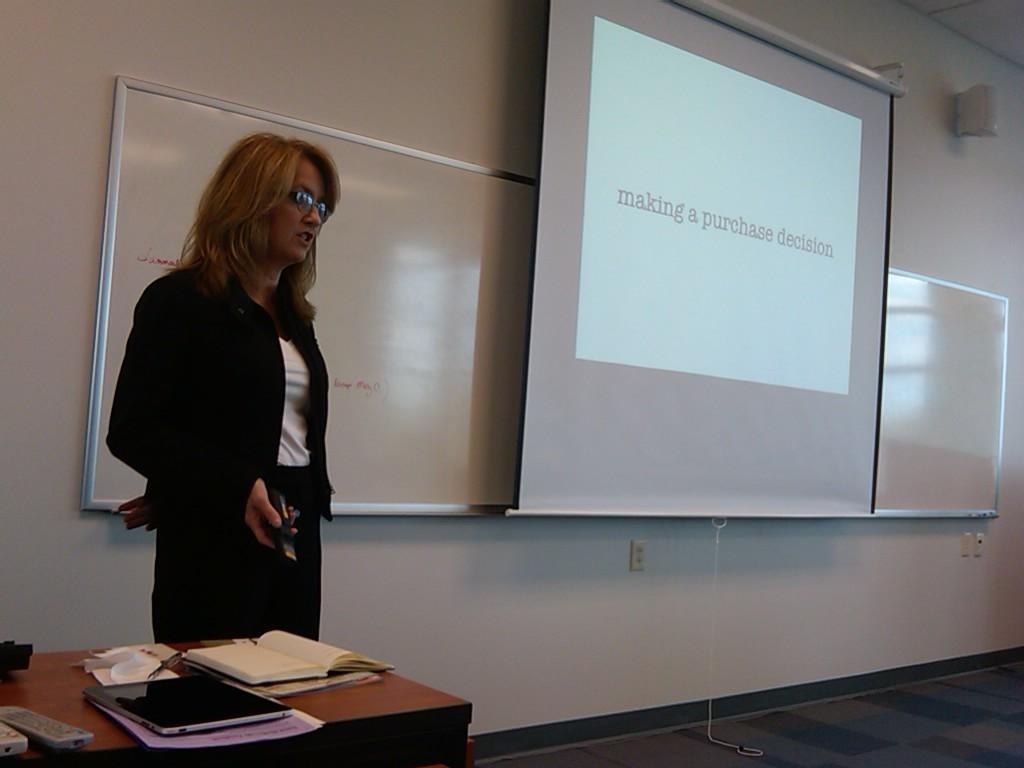Who is present in the image? There is a woman in the image. What is the woman doing in the image? The woman is standing in the image. What object is the woman holding in her hand? The woman is holding a remote in her hand. What items are on the table in the image? There is a book, a laptop, and a paper on the table in the image. What type of business is being conducted in the image? There is no indication of a business being conducted in the image. 